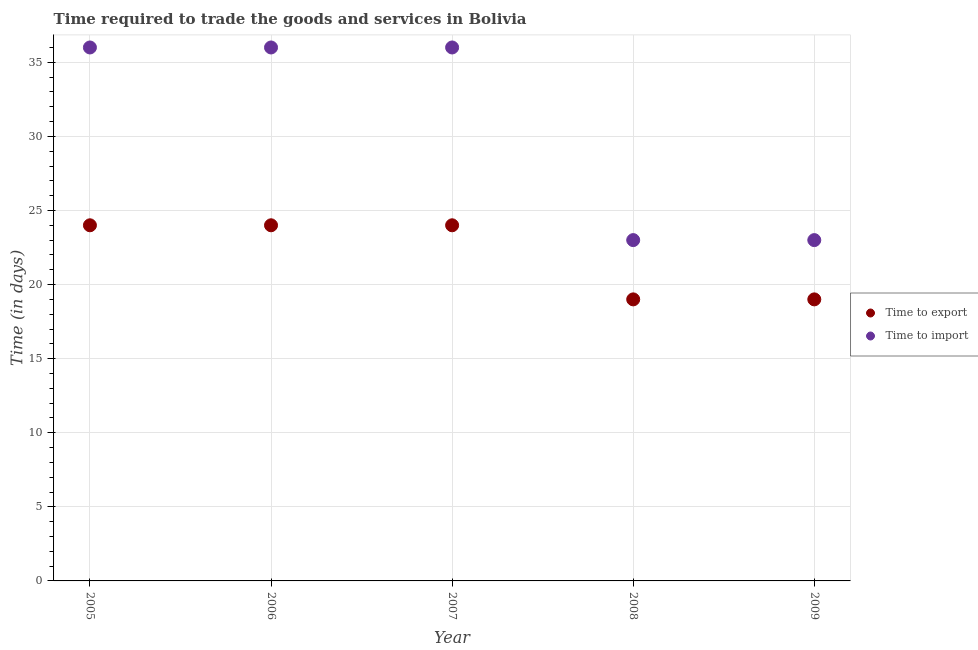What is the time to import in 2006?
Keep it short and to the point. 36. Across all years, what is the maximum time to export?
Keep it short and to the point. 24. Across all years, what is the minimum time to export?
Ensure brevity in your answer.  19. In which year was the time to import maximum?
Offer a terse response. 2005. In which year was the time to import minimum?
Make the answer very short. 2008. What is the total time to import in the graph?
Your answer should be compact. 154. What is the difference between the time to export in 2009 and the time to import in 2005?
Your answer should be compact. -17. What is the average time to export per year?
Your answer should be very brief. 22. In the year 2008, what is the difference between the time to export and time to import?
Provide a short and direct response. -4. In how many years, is the time to export greater than 23 days?
Your response must be concise. 3. What is the ratio of the time to import in 2006 to that in 2008?
Provide a succinct answer. 1.57. Is the time to import in 2005 less than that in 2009?
Give a very brief answer. No. What is the difference between the highest and the lowest time to export?
Keep it short and to the point. 5. In how many years, is the time to export greater than the average time to export taken over all years?
Provide a short and direct response. 3. Does the time to import monotonically increase over the years?
Keep it short and to the point. No. Is the time to import strictly less than the time to export over the years?
Provide a succinct answer. No. How many dotlines are there?
Make the answer very short. 2. Does the graph contain grids?
Give a very brief answer. Yes. How many legend labels are there?
Your answer should be compact. 2. How are the legend labels stacked?
Give a very brief answer. Vertical. What is the title of the graph?
Give a very brief answer. Time required to trade the goods and services in Bolivia. Does "Secondary education" appear as one of the legend labels in the graph?
Offer a terse response. No. What is the label or title of the X-axis?
Provide a short and direct response. Year. What is the label or title of the Y-axis?
Provide a short and direct response. Time (in days). What is the Time (in days) in Time to import in 2005?
Ensure brevity in your answer.  36. What is the Time (in days) in Time to import in 2006?
Provide a short and direct response. 36. What is the Time (in days) of Time to import in 2007?
Your answer should be compact. 36. Across all years, what is the minimum Time (in days) in Time to export?
Make the answer very short. 19. What is the total Time (in days) in Time to export in the graph?
Give a very brief answer. 110. What is the total Time (in days) in Time to import in the graph?
Make the answer very short. 154. What is the difference between the Time (in days) in Time to import in 2005 and that in 2006?
Give a very brief answer. 0. What is the difference between the Time (in days) in Time to import in 2005 and that in 2008?
Your answer should be compact. 13. What is the difference between the Time (in days) in Time to export in 2005 and that in 2009?
Give a very brief answer. 5. What is the difference between the Time (in days) of Time to import in 2005 and that in 2009?
Ensure brevity in your answer.  13. What is the difference between the Time (in days) in Time to export in 2006 and that in 2008?
Offer a terse response. 5. What is the difference between the Time (in days) of Time to import in 2006 and that in 2008?
Provide a succinct answer. 13. What is the difference between the Time (in days) in Time to export in 2006 and that in 2009?
Your response must be concise. 5. What is the difference between the Time (in days) in Time to import in 2006 and that in 2009?
Your answer should be very brief. 13. What is the difference between the Time (in days) of Time to export in 2005 and the Time (in days) of Time to import in 2008?
Keep it short and to the point. 1. What is the difference between the Time (in days) in Time to export in 2005 and the Time (in days) in Time to import in 2009?
Offer a terse response. 1. What is the difference between the Time (in days) of Time to export in 2006 and the Time (in days) of Time to import in 2009?
Your answer should be compact. 1. What is the difference between the Time (in days) in Time to export in 2007 and the Time (in days) in Time to import in 2009?
Make the answer very short. 1. What is the difference between the Time (in days) of Time to export in 2008 and the Time (in days) of Time to import in 2009?
Provide a short and direct response. -4. What is the average Time (in days) in Time to export per year?
Provide a short and direct response. 22. What is the average Time (in days) in Time to import per year?
Make the answer very short. 30.8. In the year 2006, what is the difference between the Time (in days) in Time to export and Time (in days) in Time to import?
Offer a terse response. -12. What is the ratio of the Time (in days) of Time to export in 2005 to that in 2006?
Give a very brief answer. 1. What is the ratio of the Time (in days) in Time to export in 2005 to that in 2007?
Keep it short and to the point. 1. What is the ratio of the Time (in days) of Time to export in 2005 to that in 2008?
Your answer should be compact. 1.26. What is the ratio of the Time (in days) of Time to import in 2005 to that in 2008?
Ensure brevity in your answer.  1.57. What is the ratio of the Time (in days) of Time to export in 2005 to that in 2009?
Ensure brevity in your answer.  1.26. What is the ratio of the Time (in days) in Time to import in 2005 to that in 2009?
Ensure brevity in your answer.  1.57. What is the ratio of the Time (in days) in Time to export in 2006 to that in 2008?
Offer a very short reply. 1.26. What is the ratio of the Time (in days) in Time to import in 2006 to that in 2008?
Make the answer very short. 1.57. What is the ratio of the Time (in days) in Time to export in 2006 to that in 2009?
Provide a short and direct response. 1.26. What is the ratio of the Time (in days) in Time to import in 2006 to that in 2009?
Keep it short and to the point. 1.57. What is the ratio of the Time (in days) of Time to export in 2007 to that in 2008?
Ensure brevity in your answer.  1.26. What is the ratio of the Time (in days) in Time to import in 2007 to that in 2008?
Your answer should be very brief. 1.57. What is the ratio of the Time (in days) of Time to export in 2007 to that in 2009?
Provide a short and direct response. 1.26. What is the ratio of the Time (in days) in Time to import in 2007 to that in 2009?
Keep it short and to the point. 1.57. What is the ratio of the Time (in days) in Time to import in 2008 to that in 2009?
Offer a very short reply. 1. 